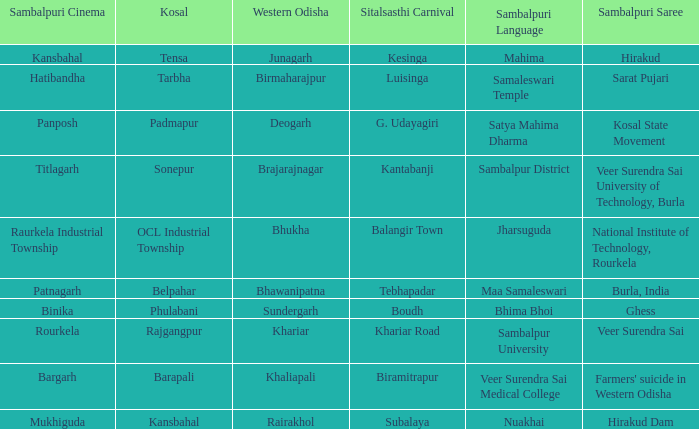What is the Kosal with a balangir town sitalsasthi carnival? OCL Industrial Township. 